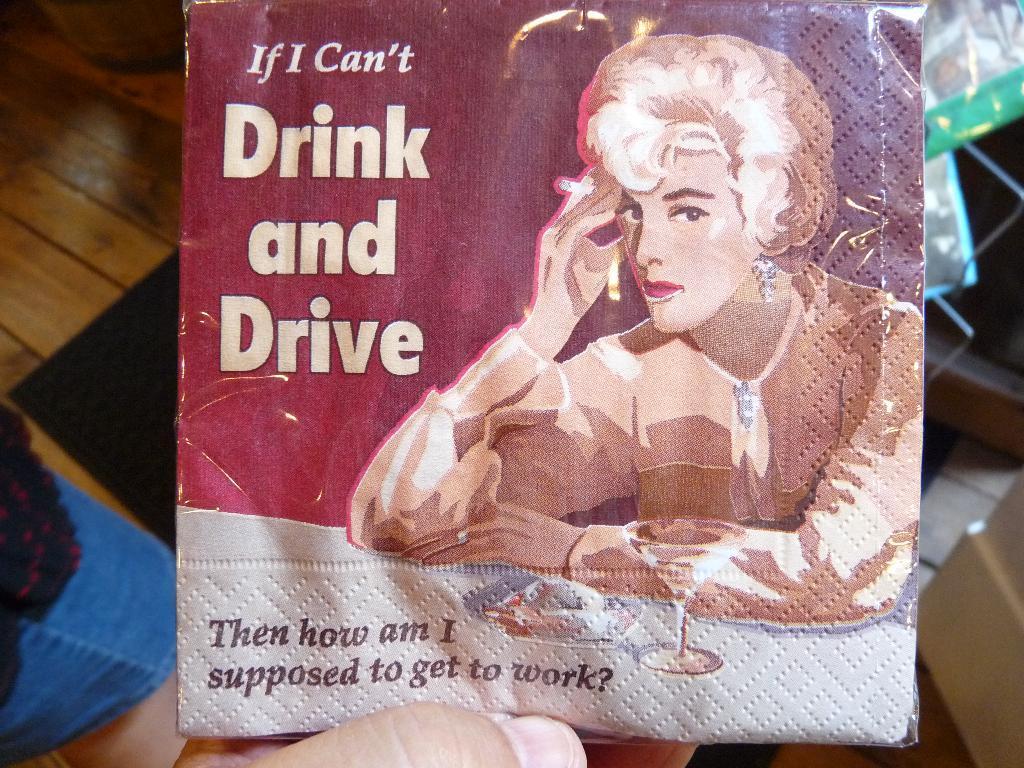How would you summarize this image in a sentence or two? This looks like a cover with the print on it. At the bottom of the image, I can see a person's finger. This looks like a wooden table. I can see few objects in the background. 